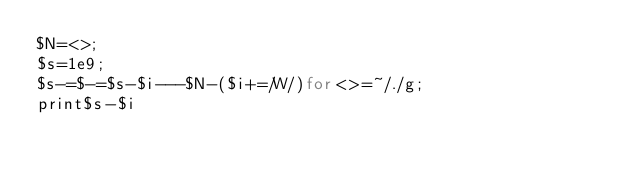Convert code to text. <code><loc_0><loc_0><loc_500><loc_500><_Perl_>$N=<>;
$s=1e9;
$s-=$-=$s-$i---$N-($i+=/W/)for<>=~/./g;
print$s-$i</code> 